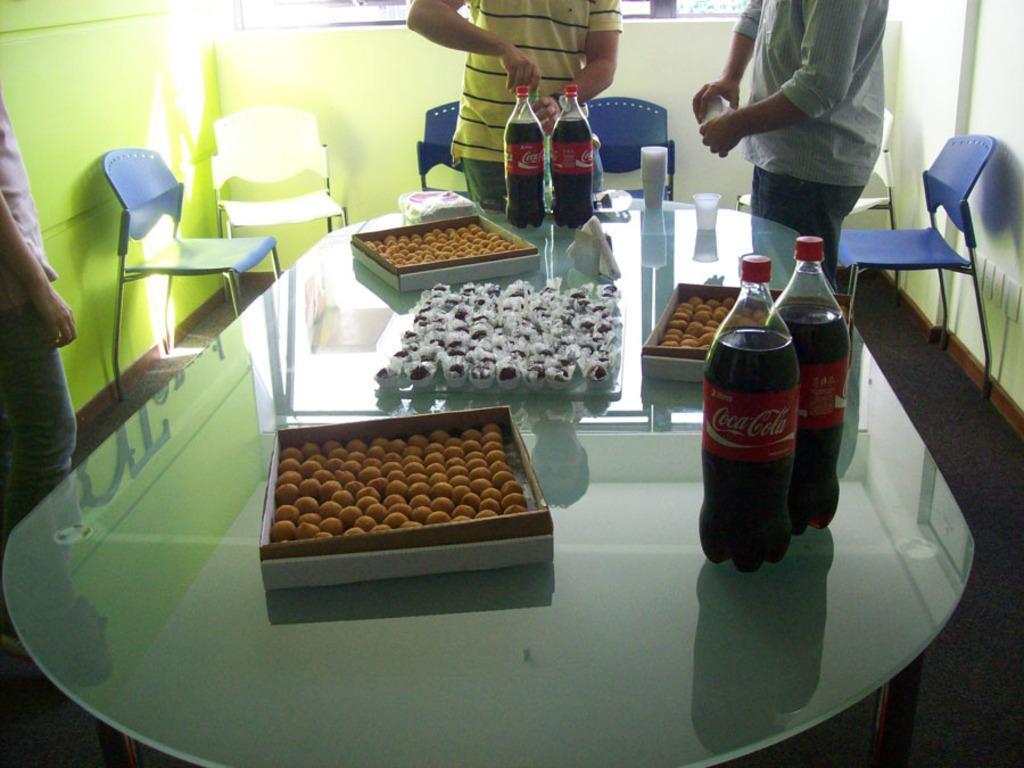Please provide a concise description of this image. As we can see in the image there is a yellow color wall, window, three people standing over here and there are chairs and tables. On table there are bottle, glasses and sweets. 